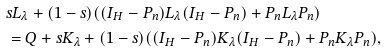Convert formula to latex. <formula><loc_0><loc_0><loc_500><loc_500>& s L _ { \lambda } + ( 1 - s ) ( ( I _ { H } - P _ { n } ) L _ { \lambda } ( I _ { H } - P _ { n } ) + P _ { n } L _ { \lambda } P _ { n } ) \\ & = Q + s K _ { \lambda } + ( 1 - s ) ( ( I _ { H } - P _ { n } ) K _ { \lambda } ( I _ { H } - P _ { n } ) + P _ { n } K _ { \lambda } P _ { n } ) ,</formula> 